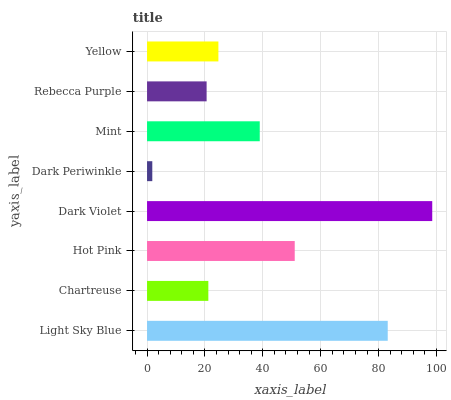Is Dark Periwinkle the minimum?
Answer yes or no. Yes. Is Dark Violet the maximum?
Answer yes or no. Yes. Is Chartreuse the minimum?
Answer yes or no. No. Is Chartreuse the maximum?
Answer yes or no. No. Is Light Sky Blue greater than Chartreuse?
Answer yes or no. Yes. Is Chartreuse less than Light Sky Blue?
Answer yes or no. Yes. Is Chartreuse greater than Light Sky Blue?
Answer yes or no. No. Is Light Sky Blue less than Chartreuse?
Answer yes or no. No. Is Mint the high median?
Answer yes or no. Yes. Is Yellow the low median?
Answer yes or no. Yes. Is Yellow the high median?
Answer yes or no. No. Is Rebecca Purple the low median?
Answer yes or no. No. 